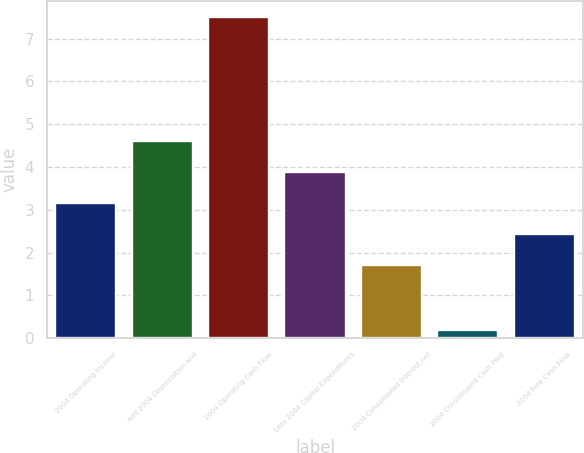Convert chart. <chart><loc_0><loc_0><loc_500><loc_500><bar_chart><fcel>2004 Operating Income<fcel>Add 2004 Depreciation and<fcel>2004 Operating Cash Flow<fcel>Less 2004 Capital Expenditures<fcel>2004 Consolidated Interest net<fcel>2004 Consolidated Cash Paid<fcel>2004 Free Cash Flow<nl><fcel>3.16<fcel>4.62<fcel>7.5<fcel>3.89<fcel>1.7<fcel>0.2<fcel>2.43<nl></chart> 